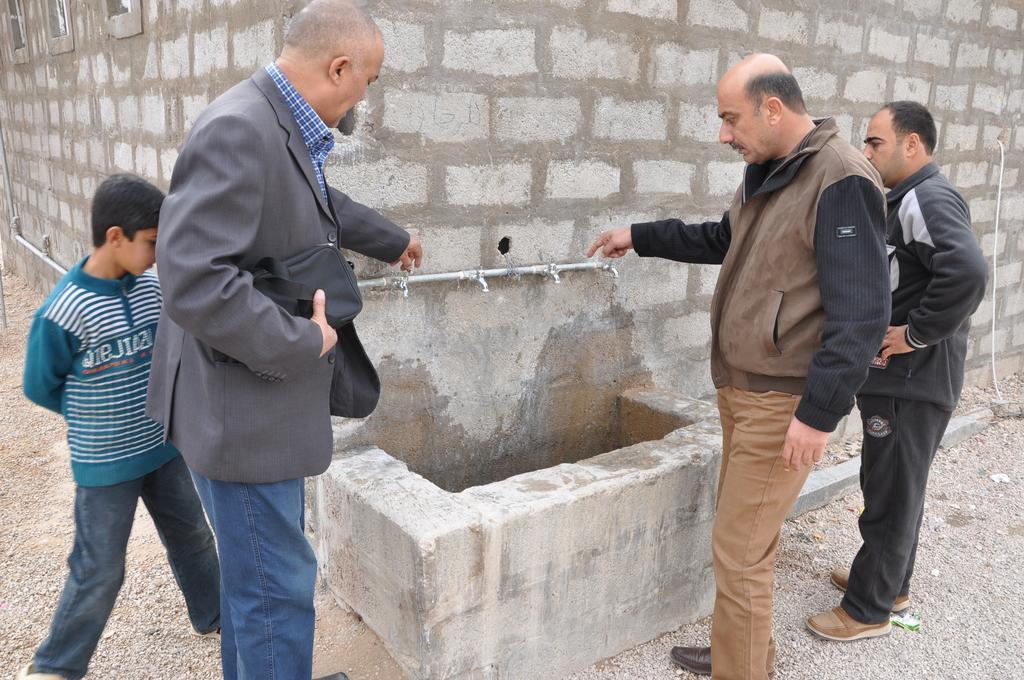Could you give a brief overview of what you see in this image? In this picture we can see group of people, in front of them we can find few taps on the wall. 